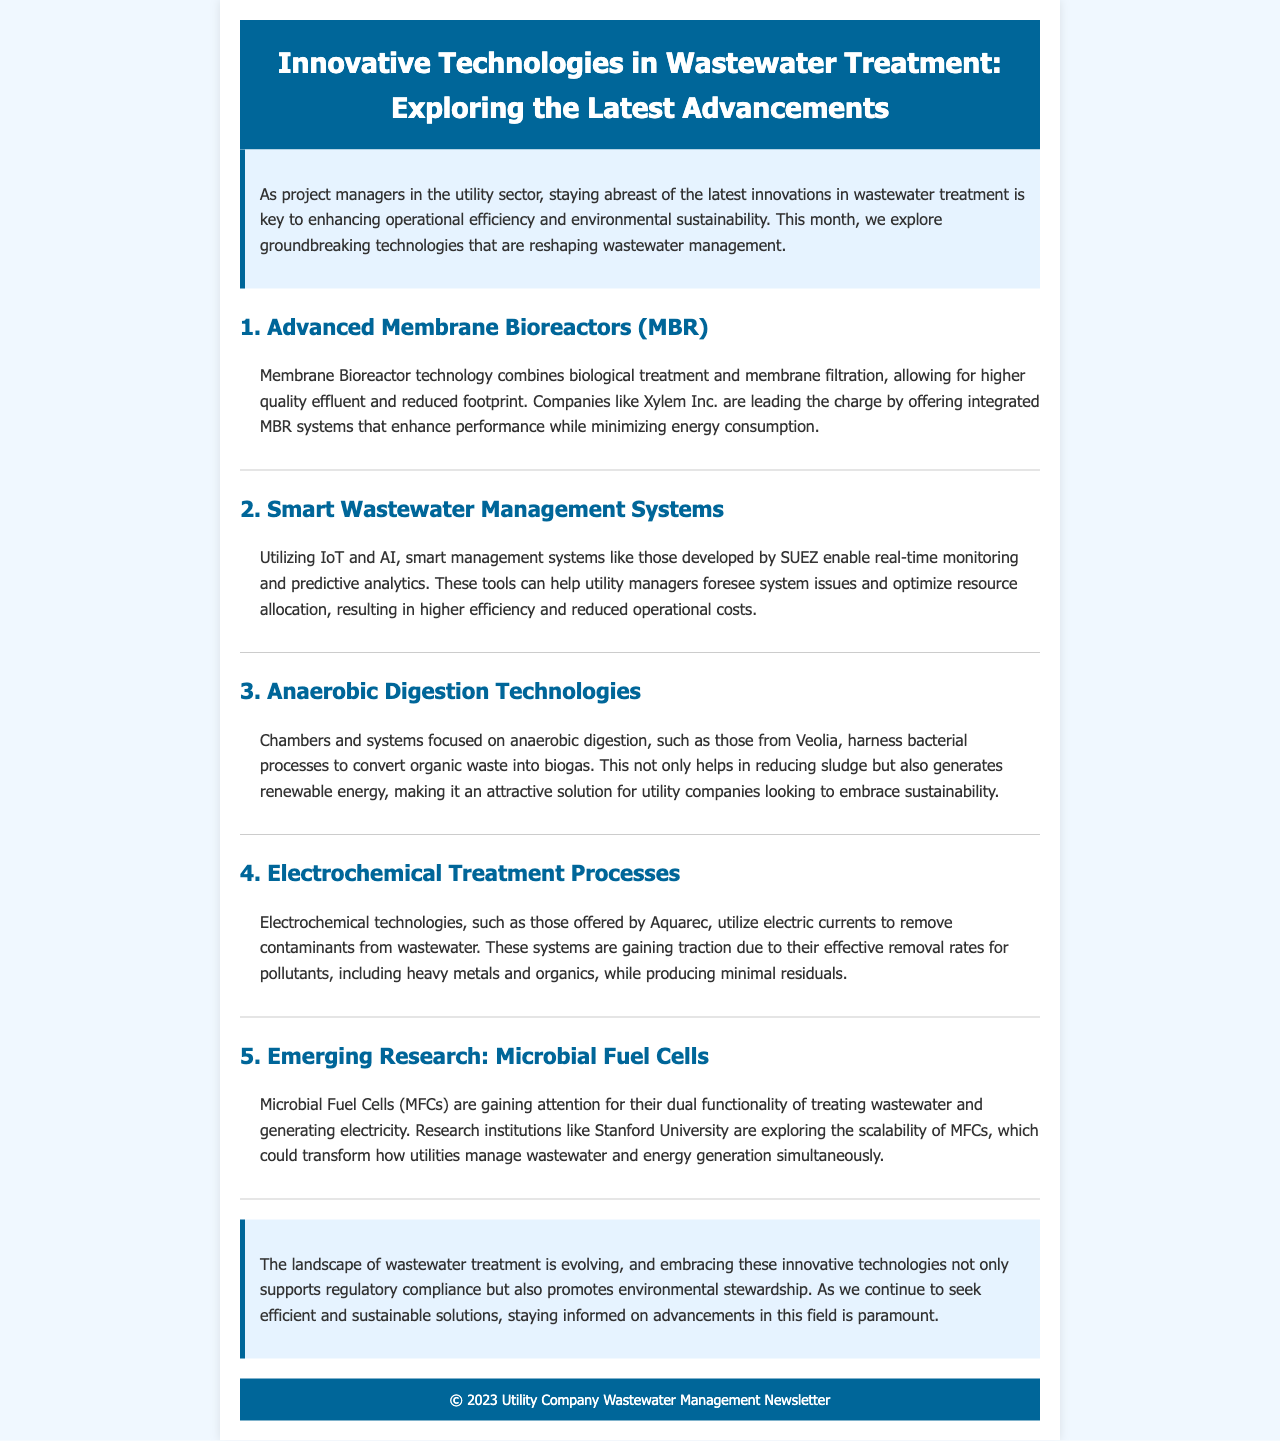what is the title of the newsletter? The title of the newsletter is provided in the header section of the document.
Answer: Innovative Technologies in Wastewater Treatment: Exploring the Latest Advancements who is mentioned as a leader in Advanced Membrane Bioreactors technology? The document mentions a specific company that is leading in this technology.
Answer: Xylem Inc what technology is being utilized alongside IoT in wastewater management systems? The document states that a specific technology combined with IoT is utilized for smart management systems.
Answer: AI which company is associated with anaerobic digestion technologies? The document lists a company that specializes in this area of wastewater treatment.
Answer: Veolia what is the dual functionality of Microbial Fuel Cells? The document highlights a specific function of Microbial Fuel Cells within its content.
Answer: treating wastewater and generating electricity what is the primary benefit of applying Electrochemical Treatment Processes? The document emphasizes a key advantage provided by electrochemical technologies.
Answer: effective removal rates for pollutants 